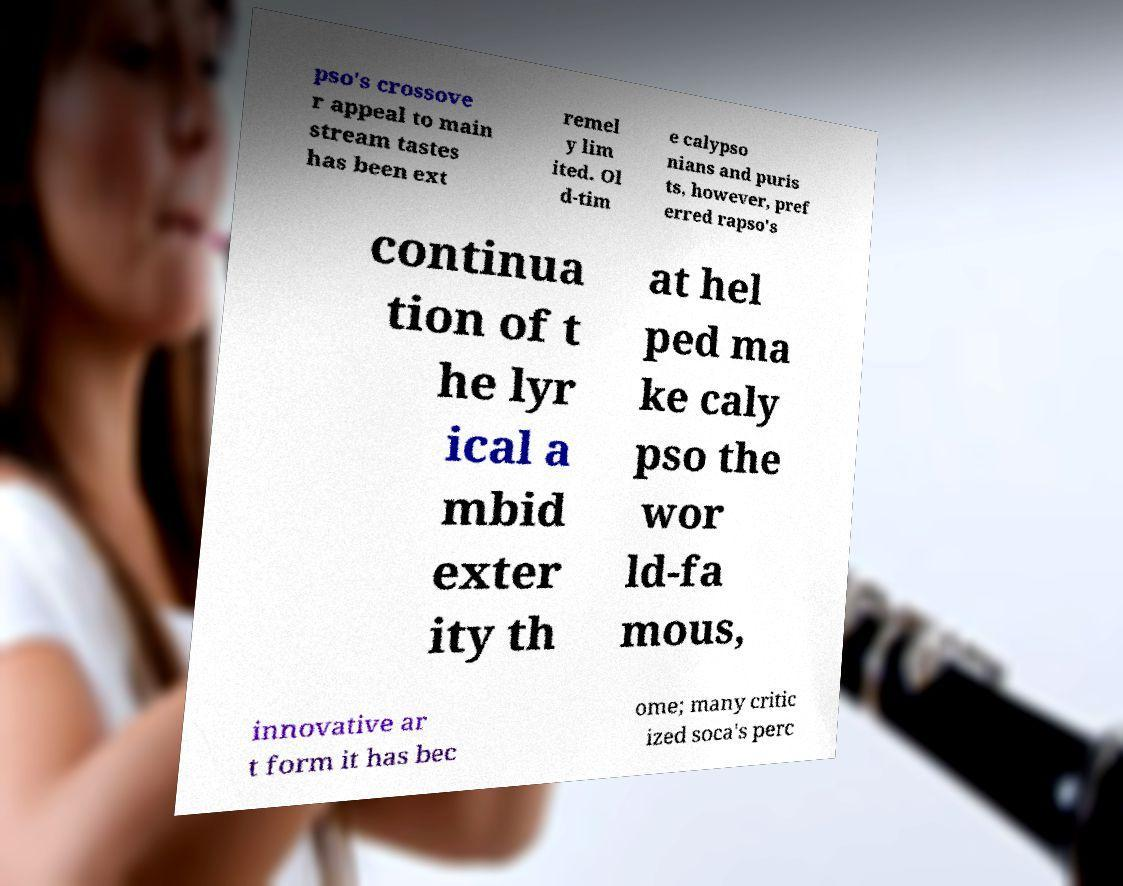Can you read and provide the text displayed in the image?This photo seems to have some interesting text. Can you extract and type it out for me? pso's crossove r appeal to main stream tastes has been ext remel y lim ited. Ol d-tim e calypso nians and puris ts, however, pref erred rapso's continua tion of t he lyr ical a mbid exter ity th at hel ped ma ke caly pso the wor ld-fa mous, innovative ar t form it has bec ome; many critic ized soca's perc 